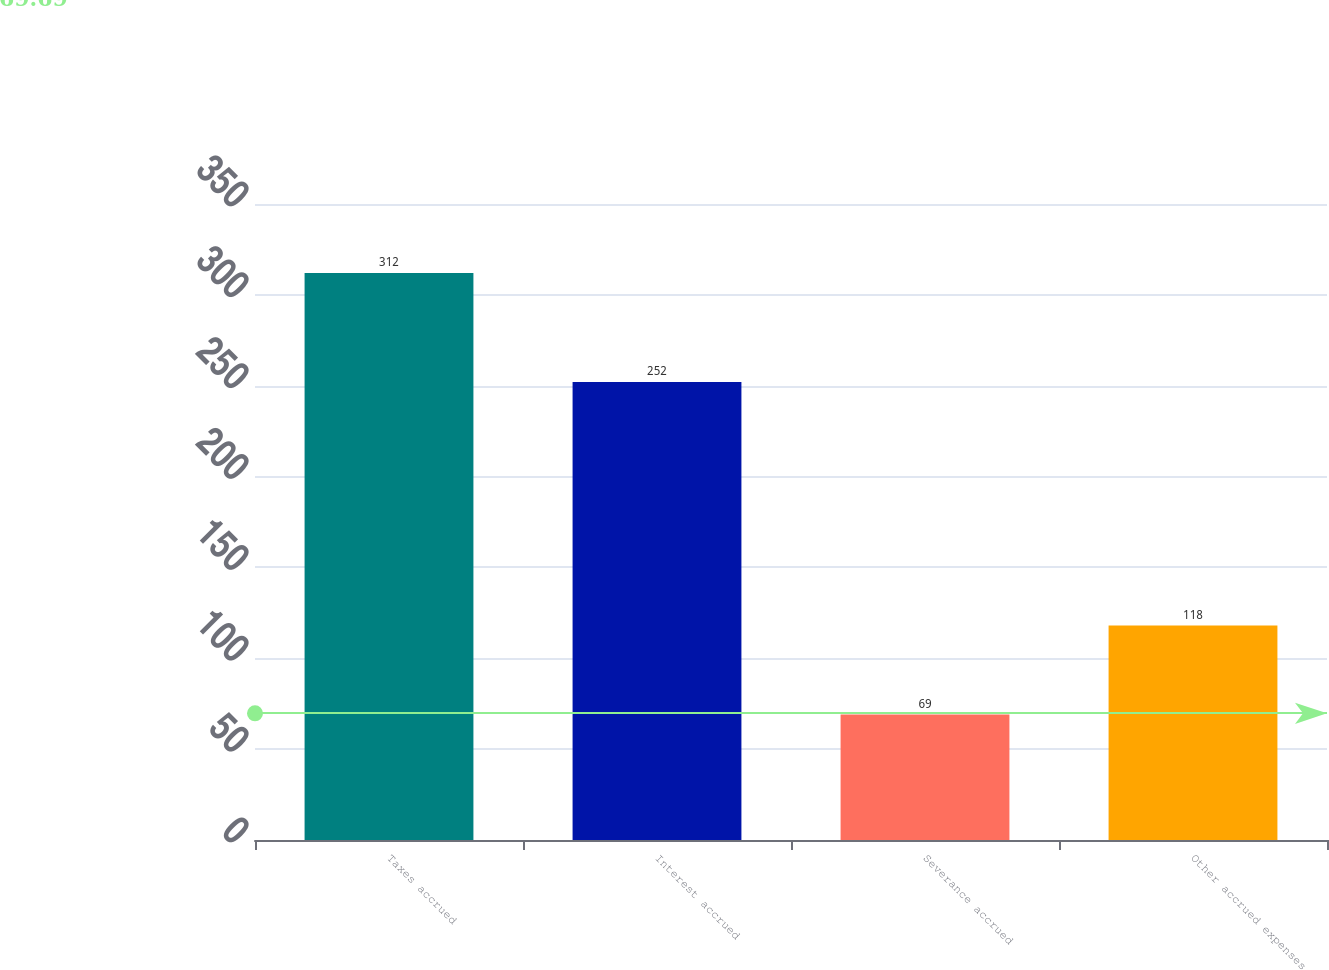Convert chart to OTSL. <chart><loc_0><loc_0><loc_500><loc_500><bar_chart><fcel>Taxes accrued<fcel>Interest accrued<fcel>Severance accrued<fcel>Other accrued expenses<nl><fcel>312<fcel>252<fcel>69<fcel>118<nl></chart> 